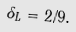<formula> <loc_0><loc_0><loc_500><loc_500>\delta _ { L } = 2 / 9 .</formula> 